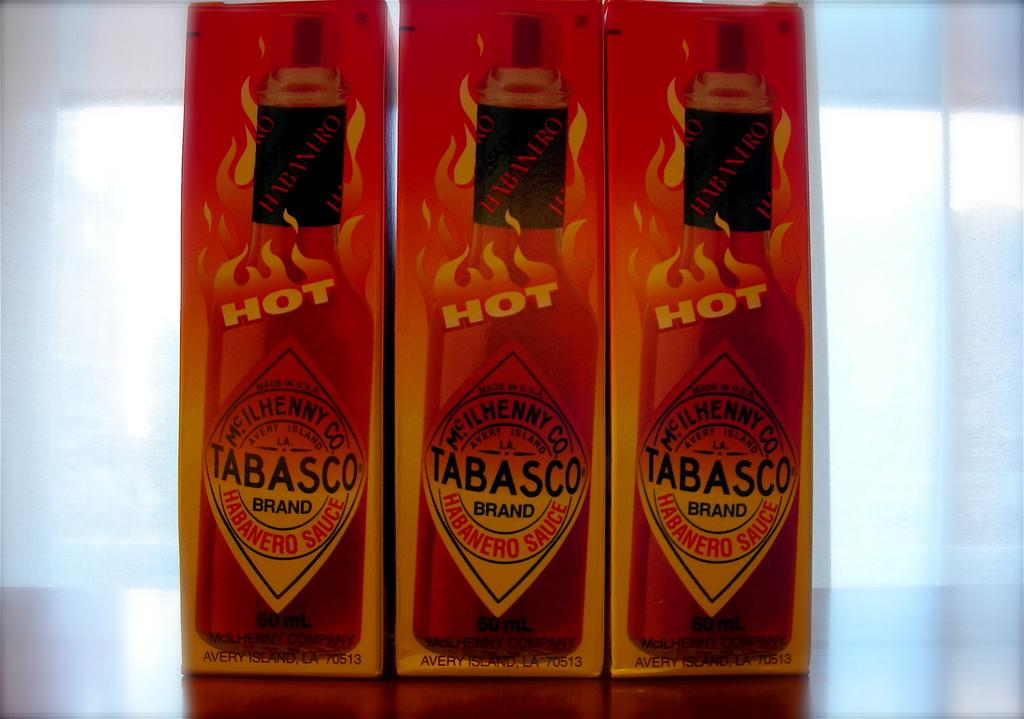<image>
Render a clear and concise summary of the photo. Three bottles of Tabasco sauce in their boxes where the word hot is displayed. 